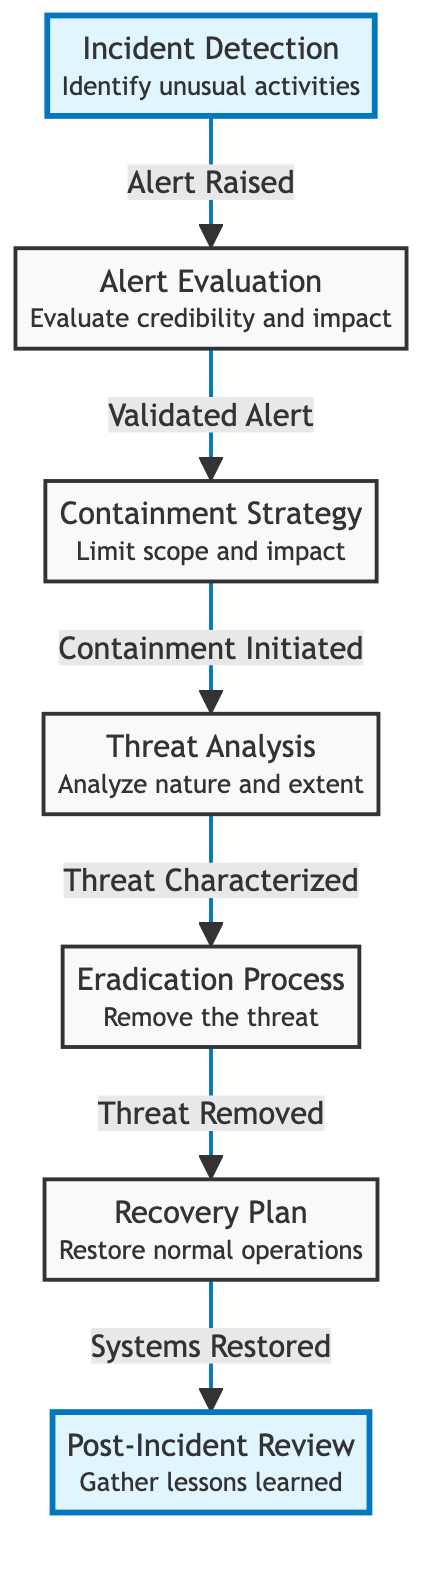What is the first step in the incident response workflow? The diagram indicates that "Incident Detection" is the very first node connected to the workflow, representing the initial step to identify unusual activities.
Answer: Incident Detection How many nodes are there in the diagram? By counting all distinct labeled nodes in the diagram, there are seven nodes present, which represent various steps in the incident response workflow.
Answer: 7 What is the relationship between containment strategy and threat analysis? The diagram shows a directed edge from "Containment Strategy" to "Threat Analysis,” indicating that once containment is initiated, the next step is to analyze the nature and extent of the threat.
Answer: Containment Initiated What happens after the threat is characterized? According to the flowchart, once the threat is characterized in "Threat Analysis," the next step is the "Eradication Process," which involves removing the threat.
Answer: Eradication Process What is the final step in the workflow? The last node shown in the diagram is "Post-Incident Review," which is depicted as the final stage where lessons learned are gathered after the recovery plan is executed.
Answer: Post-Incident Review Which step comes after alert evaluation? Following the "Alert Evaluation" step, the diagram indicates that the next step is "Containment Strategy." This means after evaluating alerts, a strategy is developed to contain any threats.
Answer: Containment Strategy How many distinct actions are conducted after threat analysis? The diagram presents two distinct actions following "Threat Analysis": first, the "Eradication Process" and then the "Recovery Plan." This means there are two actions taken after analyzing the threat.
Answer: 2 What step focuses on restoring operations? The "Recovery Plan" node focuses on restoring normal operations, as indicated by its definition in the diagram.
Answer: Recovery Plan What phase involves gathering lessons learned? The phase referred to as "Post-Incident Review" specifically involves gathering and reviewing lessons learned, as illustrated in the diagram.
Answer: Post-Incident Review 